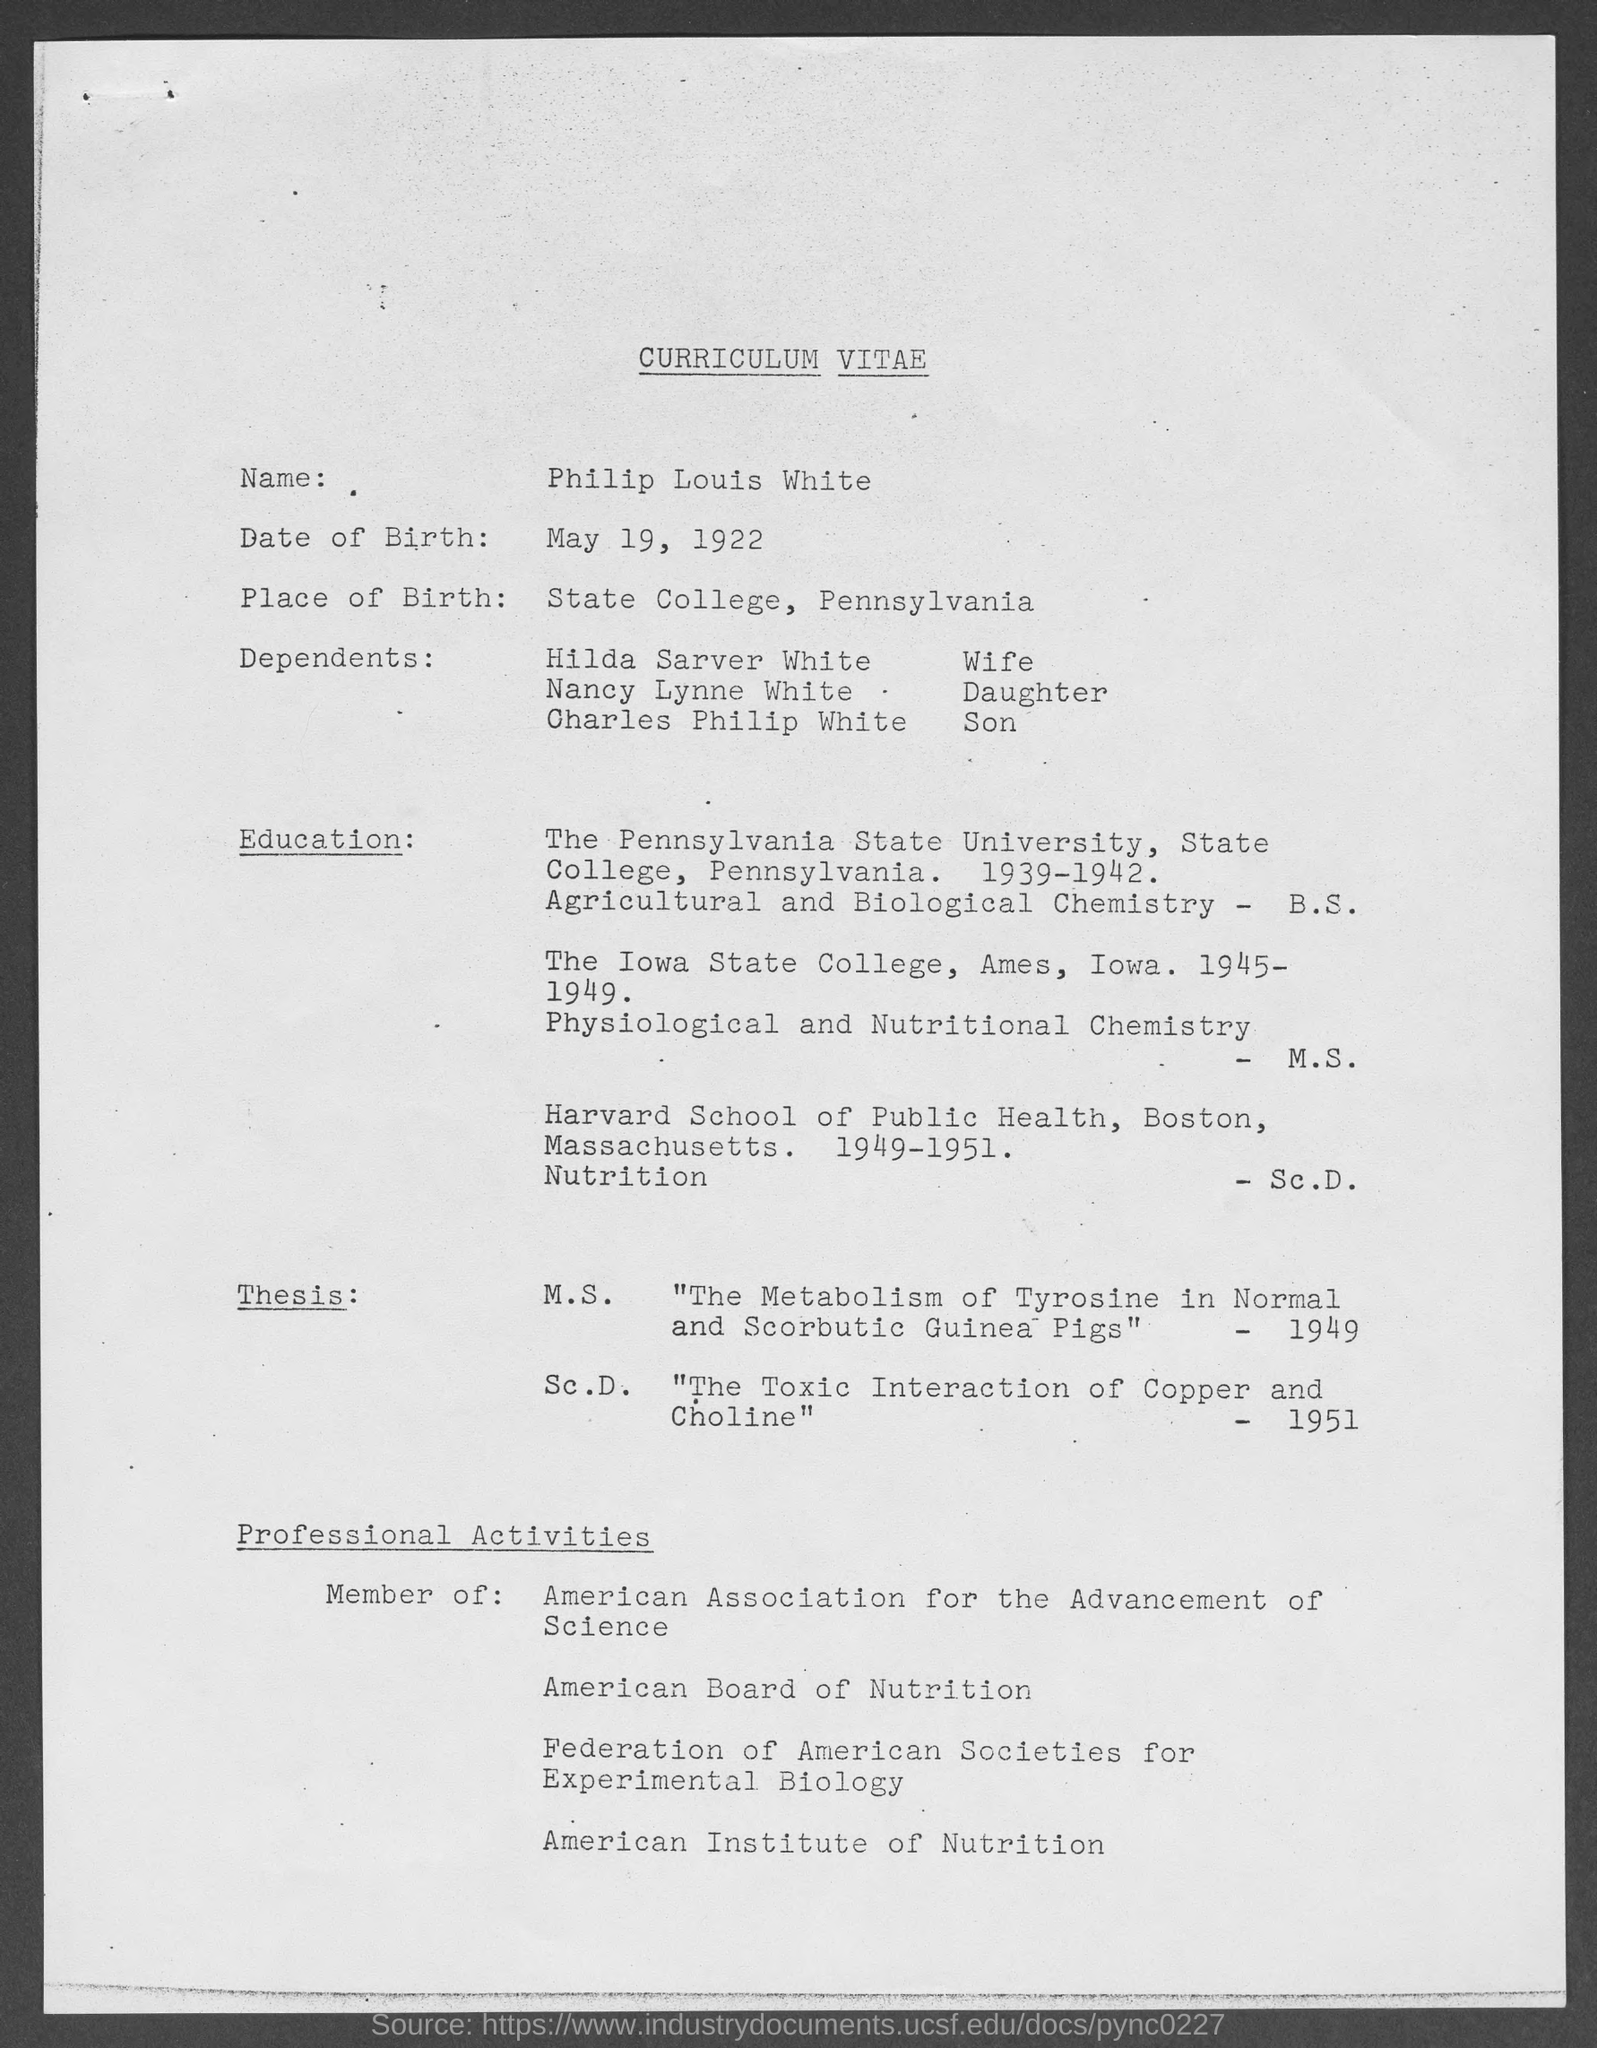Highlight a few significant elements in this photo. The date of birth is May 19, 1922. The place of birth of the person is State College, Pennsylvania. The person named Philip Louis White is the one whose curriculum vitae is being referred to. 